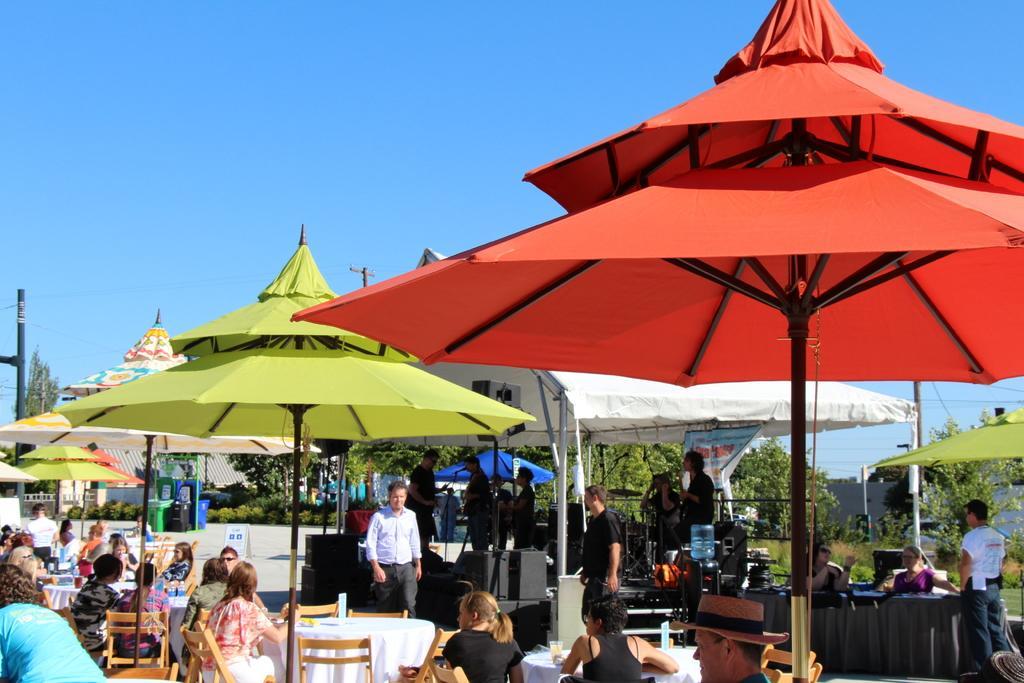Can you describe this image briefly? This picture is clicked outside. In the foreground we can see the group of persons sitting on the chairs and we can see the tables and the metal rods, some musical instruments and we can see the umbrella. In the background we can see the sky, trees, plants, group of persons, metal rods and many other objects. 